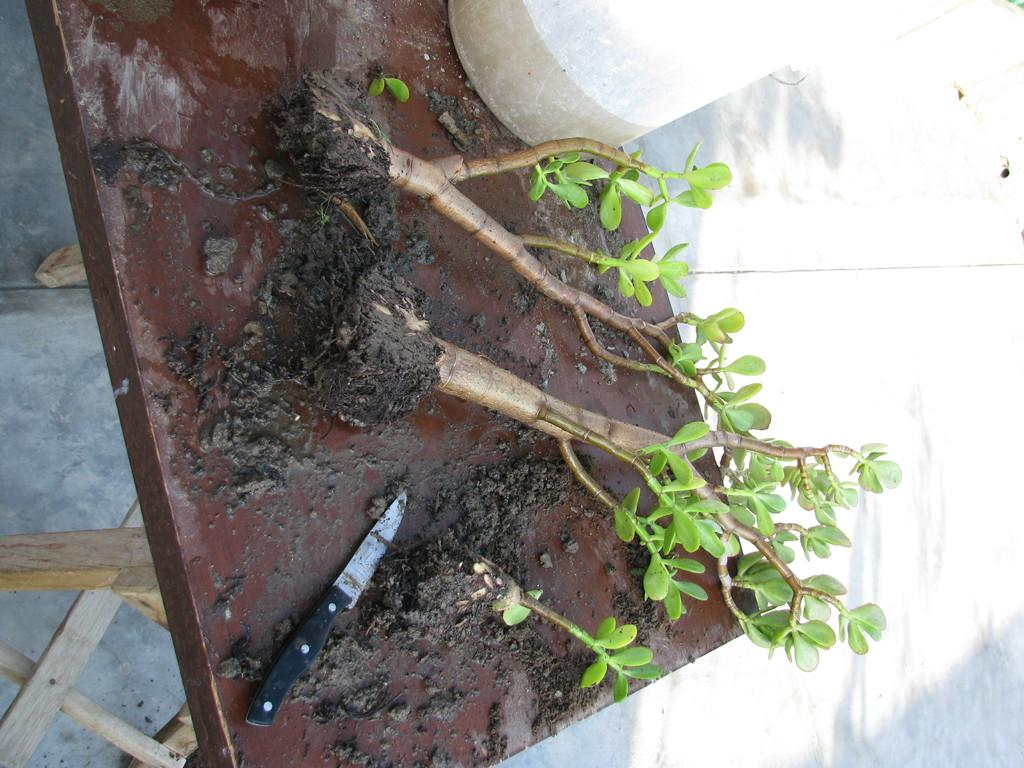How many plants are visible in the image? There are two plants in the image. What object is placed on the table in the image? There is a knife placed on a table in the image. What item is used to water the plants in the image? There is a plastic water can beside the plant in the image. What type of love is expressed between the plants in the image? There is no indication of love or emotion between the plants in the image, as they are inanimate objects. 